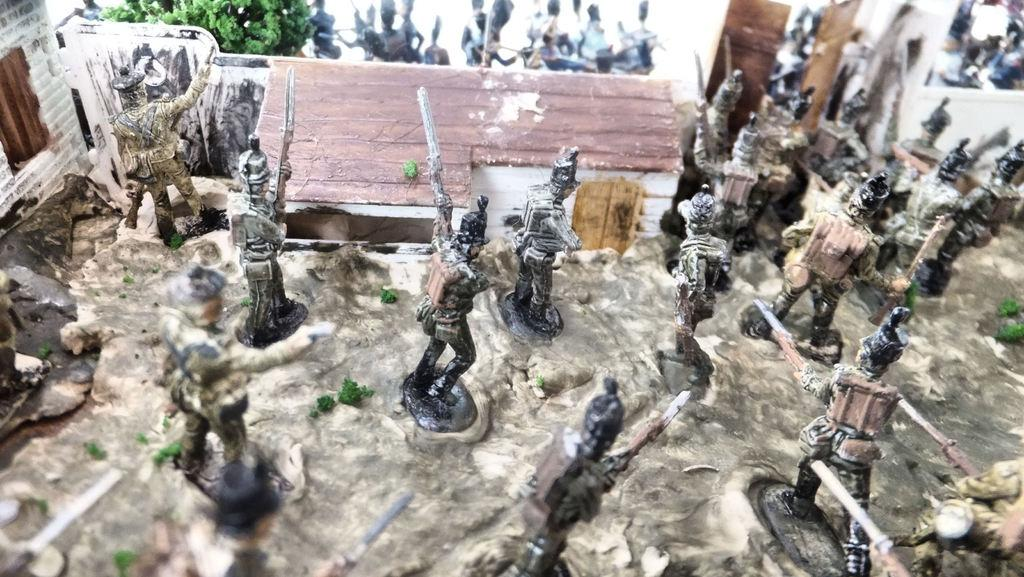What type of toys are present in the image? There are toys in the shape of people and a house in the image. Can you describe the other toys in the image? Unfortunately, the facts provided do not specify the other toys in the image. What is the purpose of the toys in the shape of people? The purpose of the toys in the shape of people is not mentioned in the facts provided. What language do the toys in the shape of people speak in the image? There is no indication in the image that the toys are capable of speaking, nor is any language mentioned. 